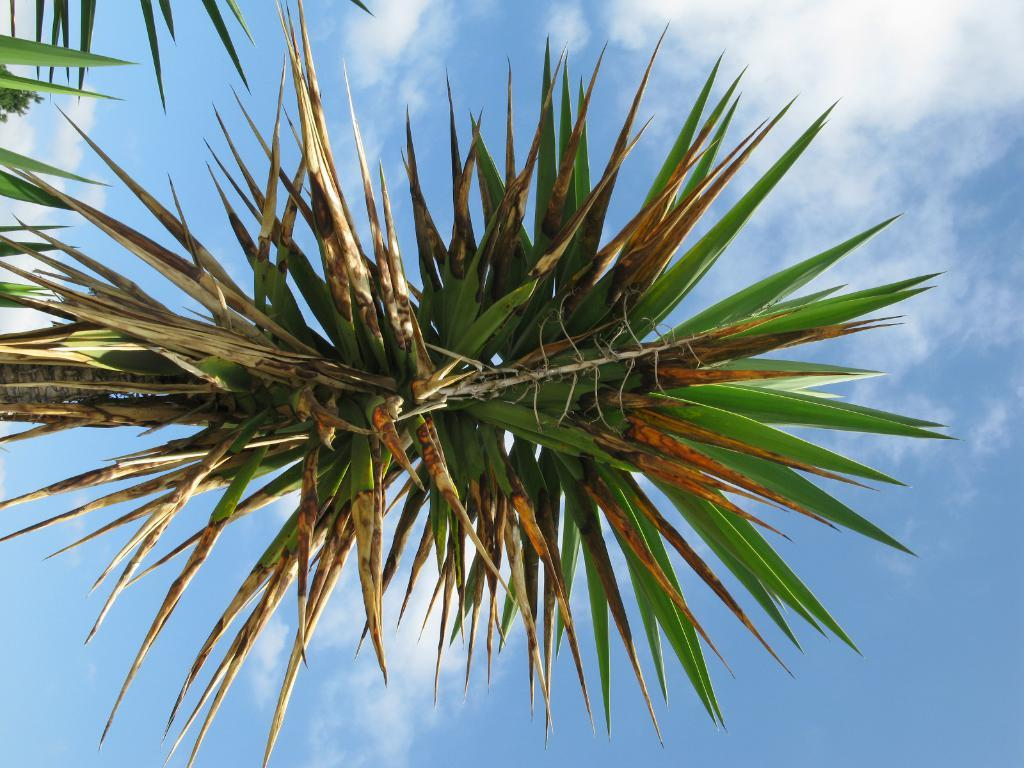What type of plant can be seen in the image? There is a big tree and a small tree in the image. What part of the trees is visible in the image? Leaves can be seen in the image. What is visible in the background of the image? The sky is visible in the background of the image. How many chairs can be seen in the image? There are no chairs present in the image. What type of skin is visible on the small tree in the image? There is no skin visible in the image; it is a photograph of trees and the sky. 